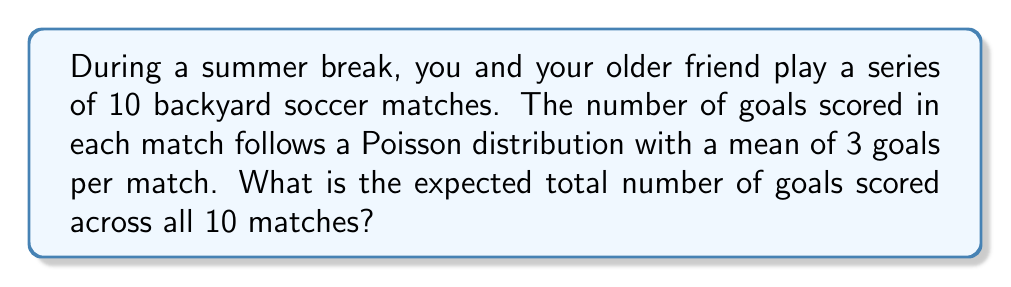What is the answer to this math problem? Let's approach this step-by-step:

1) First, we need to understand what we're given:
   - There are 10 matches
   - The number of goals in each match follows a Poisson distribution
   - The mean (λ) of this Poisson distribution is 3 goals per match

2) In a Poisson distribution, the expected value (mean) is equal to λ. So for a single match, the expected number of goals is 3.

3) Now, we need to consider all 10 matches. We can use the linearity of expectation here. This property states that the expected value of a sum of random variables is equal to the sum of their individual expected values, regardless of whether they are independent or not.

4) Let $X_i$ be the random variable representing the number of goals in match $i$, where $i$ goes from 1 to 10.

5) The total number of goals across all matches is $X = X_1 + X_2 + ... + X_{10}$

6) Using the linearity of expectation:

   $$E[X] = E[X_1 + X_2 + ... + X_{10}] = E[X_1] + E[X_2] + ... + E[X_{10}]$$

7) Since each $X_i$ has the same expected value of 3:

   $$E[X] = 3 + 3 + ... + 3 \text{ (10 times)} = 10 \times 3 = 30$$

Therefore, the expected total number of goals scored across all 10 matches is 30.
Answer: 30 goals 